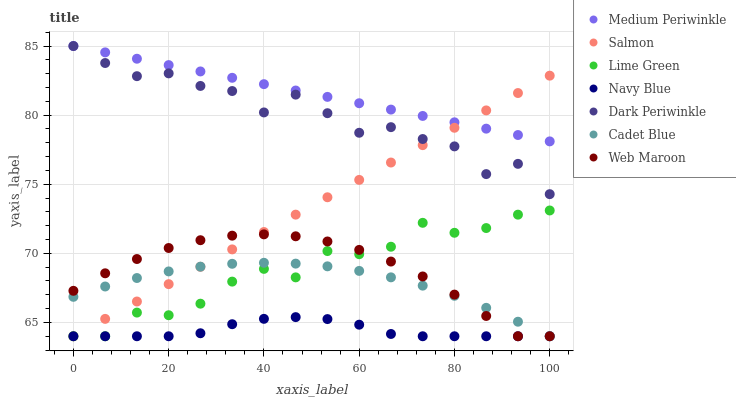Does Navy Blue have the minimum area under the curve?
Answer yes or no. Yes. Does Medium Periwinkle have the maximum area under the curve?
Answer yes or no. Yes. Does Salmon have the minimum area under the curve?
Answer yes or no. No. Does Salmon have the maximum area under the curve?
Answer yes or no. No. Is Salmon the smoothest?
Answer yes or no. Yes. Is Dark Periwinkle the roughest?
Answer yes or no. Yes. Is Medium Periwinkle the smoothest?
Answer yes or no. No. Is Medium Periwinkle the roughest?
Answer yes or no. No. Does Cadet Blue have the lowest value?
Answer yes or no. Yes. Does Medium Periwinkle have the lowest value?
Answer yes or no. No. Does Dark Periwinkle have the highest value?
Answer yes or no. Yes. Does Salmon have the highest value?
Answer yes or no. No. Is Cadet Blue less than Dark Periwinkle?
Answer yes or no. Yes. Is Dark Periwinkle greater than Navy Blue?
Answer yes or no. Yes. Does Dark Periwinkle intersect Medium Periwinkle?
Answer yes or no. Yes. Is Dark Periwinkle less than Medium Periwinkle?
Answer yes or no. No. Is Dark Periwinkle greater than Medium Periwinkle?
Answer yes or no. No. Does Cadet Blue intersect Dark Periwinkle?
Answer yes or no. No. 